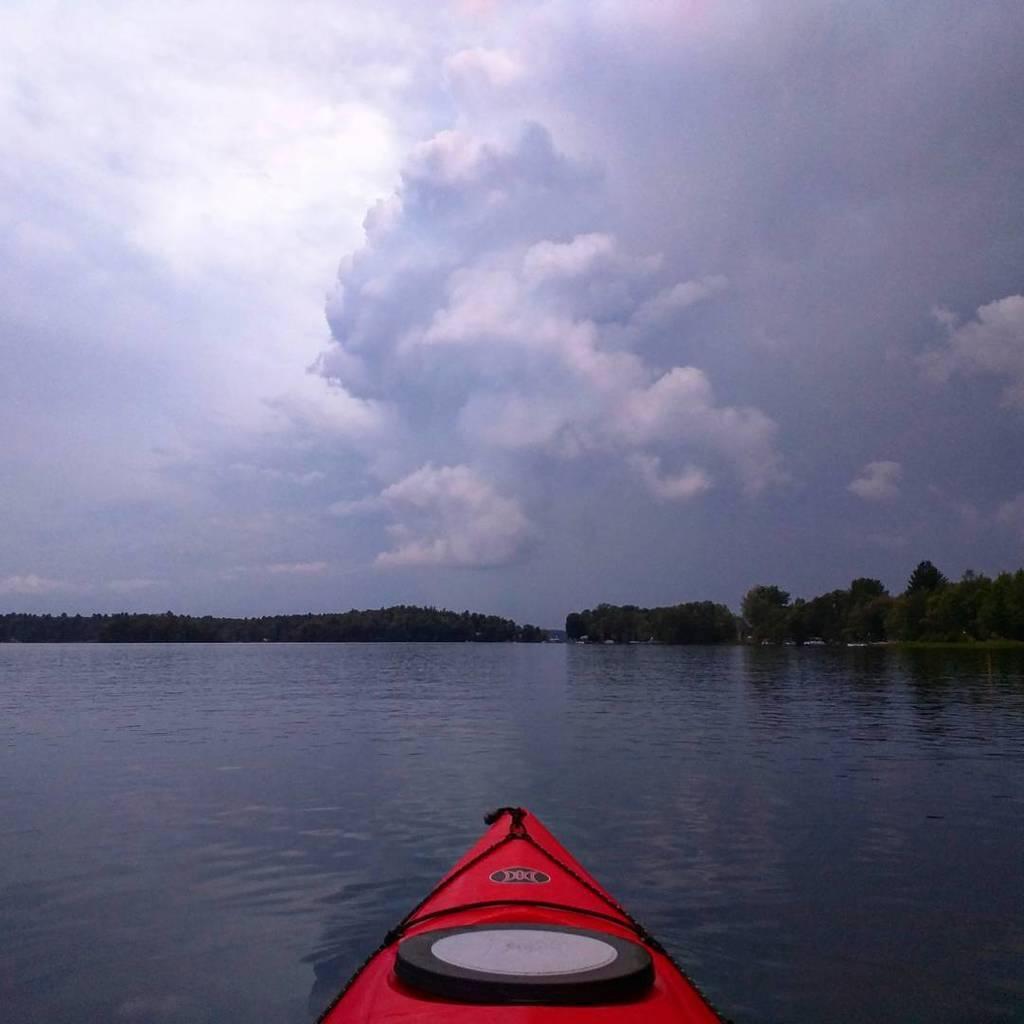How would you summarize this image in a sentence or two? In the middle it is a boat, which is in red color and this is water. In the long back side there are trees. 